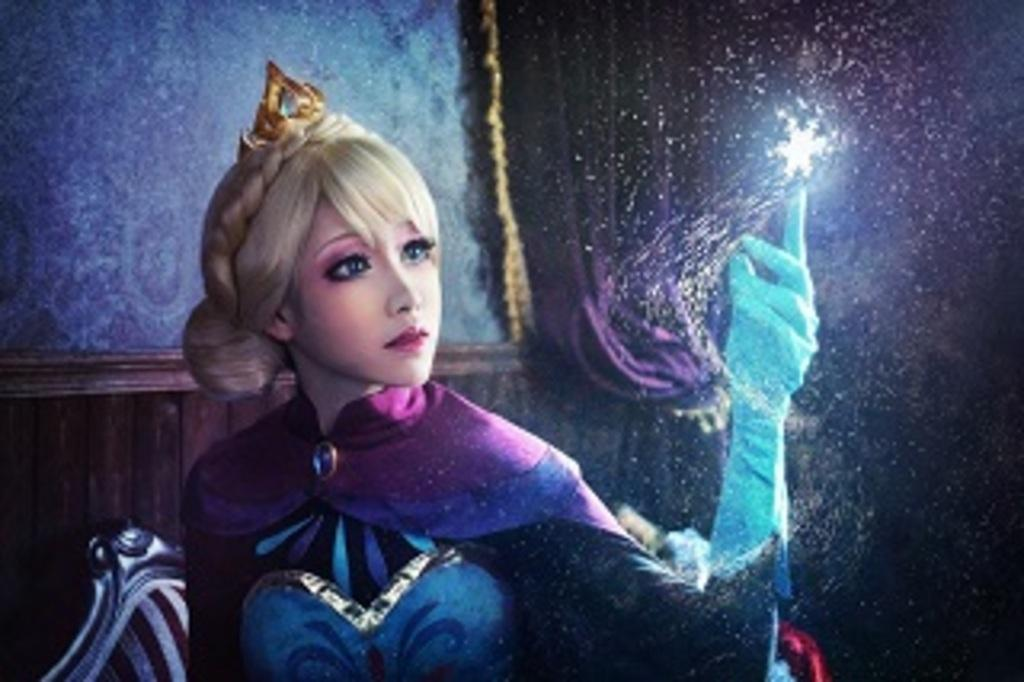What type of picture is in the image? The image contains an animated picture. Who is present in the animated picture? There is a woman in the animated picture. What can be seen in the background of the animated picture? There is a wall, a curtain, and objects in the background of the animated picture. What is the purpose of the tramp in the animated picture? There is no tramp present in the animated picture. 